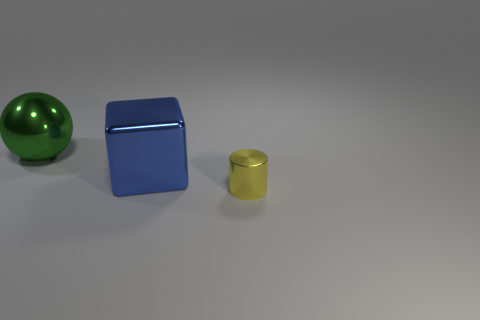Add 3 green shiny objects. How many objects exist? 6 Subtract all cylinders. How many objects are left? 2 Subtract 0 purple cubes. How many objects are left? 3 Subtract all large blue shiny objects. Subtract all big green metallic balls. How many objects are left? 1 Add 3 blue shiny things. How many blue shiny things are left? 4 Add 3 large purple metallic cylinders. How many large purple metallic cylinders exist? 3 